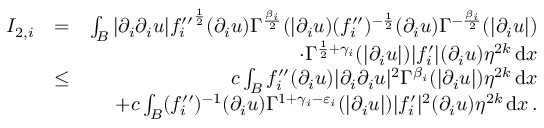Convert formula to latex. <formula><loc_0><loc_0><loc_500><loc_500>\begin{array} { r l r } { I _ { 2 , i } } & { = } & { \int _ { B } | \partial _ { i } \partial _ { i } u | { f _ { i } ^ { \prime \prime } } ^ { \frac { 1 } { 2 } } ( \partial _ { i } u ) \Gamma ^ { \frac { \beta _ { i } } { 2 } } ( | \partial _ { i } u ) ( f _ { i } ^ { \prime \prime } ) ^ { - \frac { 1 } { 2 } } ( \partial _ { i } u ) \Gamma ^ { - \frac { \beta _ { i } } { 2 } } ( | \partial _ { i } u | ) } \\ & { \quad \cdot \Gamma ^ { \frac { 1 } { 2 } + \gamma _ { i } } ( | \partial _ { i } u | ) | f _ { i } ^ { \prime } | ( \partial _ { i } u ) \eta ^ { 2 k } \, d x } \\ & { \leq } & { c \int _ { B } { f _ { i } ^ { \prime \prime } } ( \partial _ { i } u ) | \partial _ { i } \partial _ { i } u | ^ { 2 } \Gamma ^ { \beta _ { i } } ( | \partial _ { i } u | ) \eta ^ { 2 k } \, d x } \\ & { + c \int _ { B } ( f _ { i } ^ { \prime \prime } ) ^ { - 1 } ( \partial _ { i } u ) \Gamma ^ { 1 + \gamma _ { i } - \varepsilon _ { i } } ( | \partial _ { i } u | ) | f _ { i } ^ { \prime } | ^ { 2 } ( \partial _ { i } u ) \eta ^ { 2 k } \, d x \, . } \end{array}</formula> 